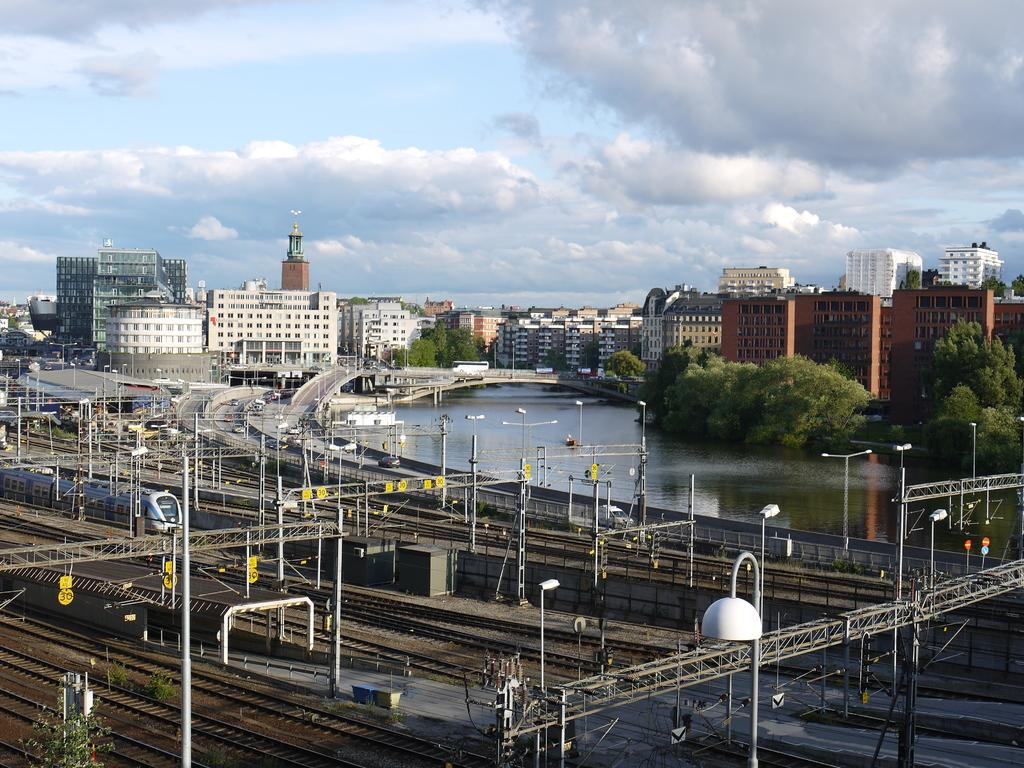What structures are present in the image? There are poles and lights in the image. What type of transportation can be seen in the image? There are trains on the tracks in the image. What can be seen in the background of the image? There are buildings, water, trees, vehicles, and clouds visible in the background of the image. What type of corn is being harvested in the image? There is no corn present in the image; it features poles, lights, trains, and various background elements. 